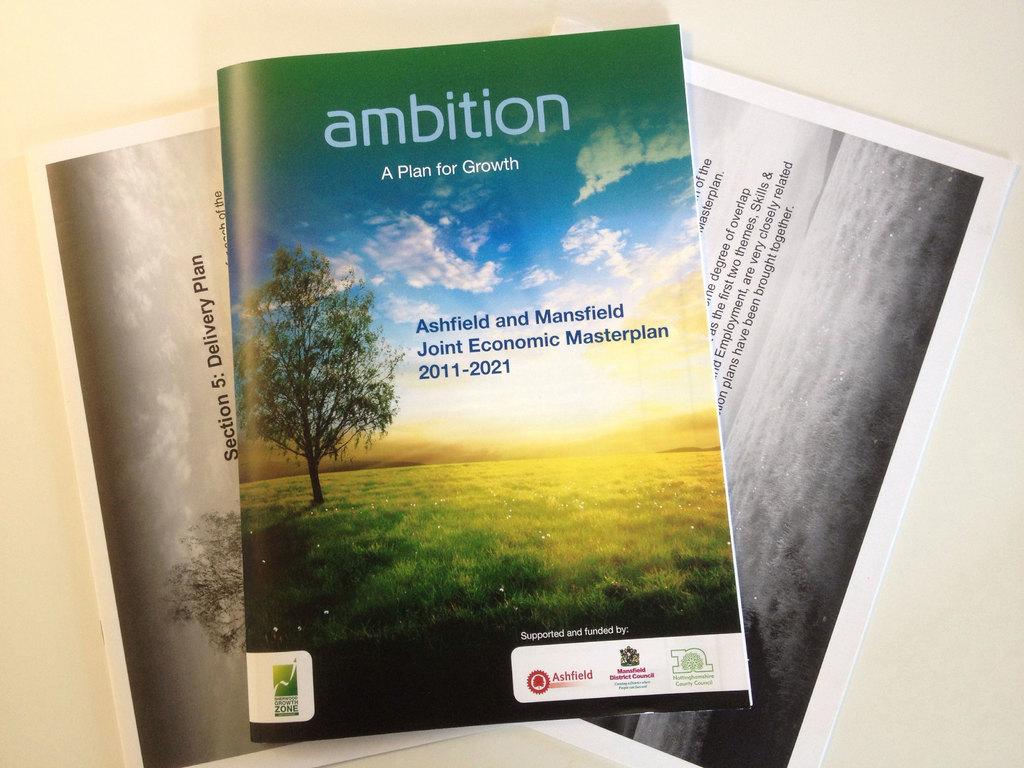What is that book for?
Offer a very short reply. Ambition. Are ashfield and mansfield names of people?
Ensure brevity in your answer.  No. 